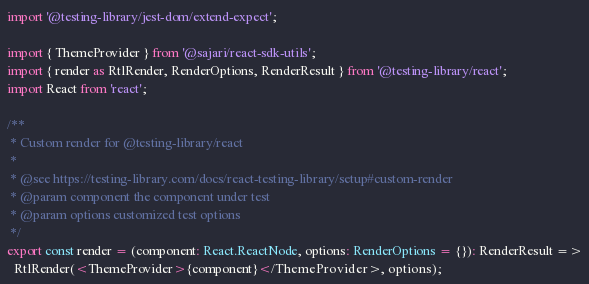<code> <loc_0><loc_0><loc_500><loc_500><_TypeScript_>import '@testing-library/jest-dom/extend-expect';

import { ThemeProvider } from '@sajari/react-sdk-utils';
import { render as RtlRender, RenderOptions, RenderResult } from '@testing-library/react';
import React from 'react';

/**
 * Custom render for @testing-library/react
 *
 * @see https://testing-library.com/docs/react-testing-library/setup#custom-render
 * @param component the component under test
 * @param options customized test options
 */
export const render = (component: React.ReactNode, options: RenderOptions = {}): RenderResult =>
  RtlRender(<ThemeProvider>{component}</ThemeProvider>, options);
</code> 